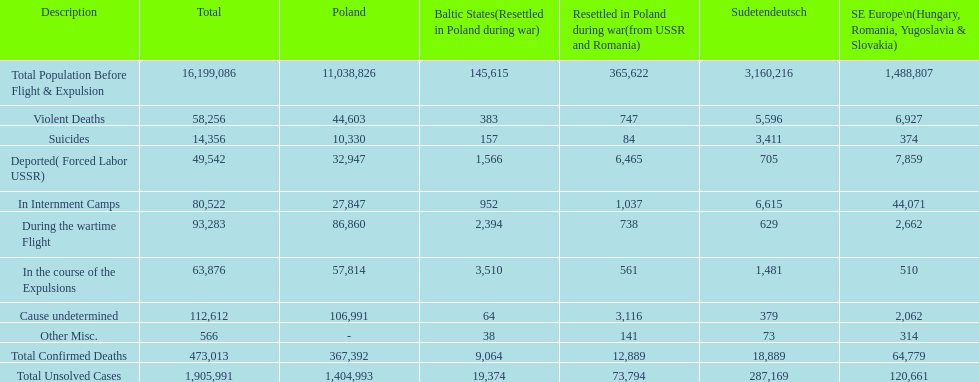Which nation experienced the higher death toll? Poland. 